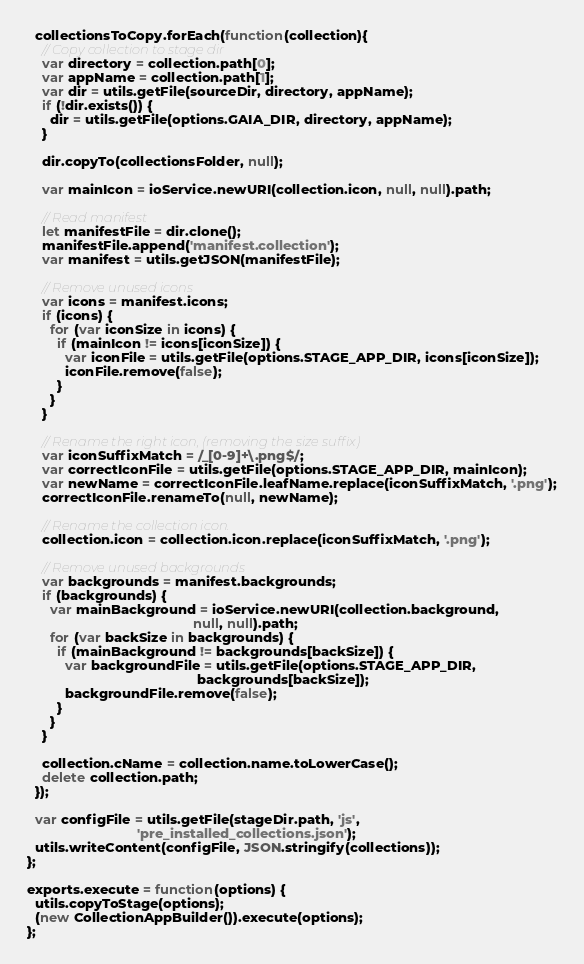<code> <loc_0><loc_0><loc_500><loc_500><_JavaScript_>
  collectionsToCopy.forEach(function(collection){
    // Copy collection to stage dir
    var directory = collection.path[0];
    var appName = collection.path[1];
    var dir = utils.getFile(sourceDir, directory, appName);
    if (!dir.exists()) {
      dir = utils.getFile(options.GAIA_DIR, directory, appName);
    }

    dir.copyTo(collectionsFolder, null);

    var mainIcon = ioService.newURI(collection.icon, null, null).path;

    // Read manifest
    let manifestFile = dir.clone();
    manifestFile.append('manifest.collection');
    var manifest = utils.getJSON(manifestFile);

    // Remove unused icons
    var icons = manifest.icons;
    if (icons) {
      for (var iconSize in icons) {
        if (mainIcon != icons[iconSize]) {
          var iconFile = utils.getFile(options.STAGE_APP_DIR, icons[iconSize]);
          iconFile.remove(false);
        }
      }
    }

    // Rename the right icon, (removing the size suffix)
    var iconSuffixMatch = /_[0-9]+\.png$/;
    var correctIconFile = utils.getFile(options.STAGE_APP_DIR, mainIcon);
    var newName = correctIconFile.leafName.replace(iconSuffixMatch, '.png');
    correctIconFile.renameTo(null, newName);

    // Rename the collection icon.
    collection.icon = collection.icon.replace(iconSuffixMatch, '.png');

    // Remove unused backgrounds
    var backgrounds = manifest.backgrounds;
    if (backgrounds) {
      var mainBackground = ioService.newURI(collection.background,
                                            null, null).path;
      for (var backSize in backgrounds) {
        if (mainBackground != backgrounds[backSize]) {
          var backgroundFile = utils.getFile(options.STAGE_APP_DIR,
                                             backgrounds[backSize]);
          backgroundFile.remove(false);
        }
      }
    }

    collection.cName = collection.name.toLowerCase();
    delete collection.path;
  });

  var configFile = utils.getFile(stageDir.path, 'js',
                             'pre_installed_collections.json');
  utils.writeContent(configFile, JSON.stringify(collections));
};

exports.execute = function(options) {
  utils.copyToStage(options);
  (new CollectionAppBuilder()).execute(options);
};
</code> 